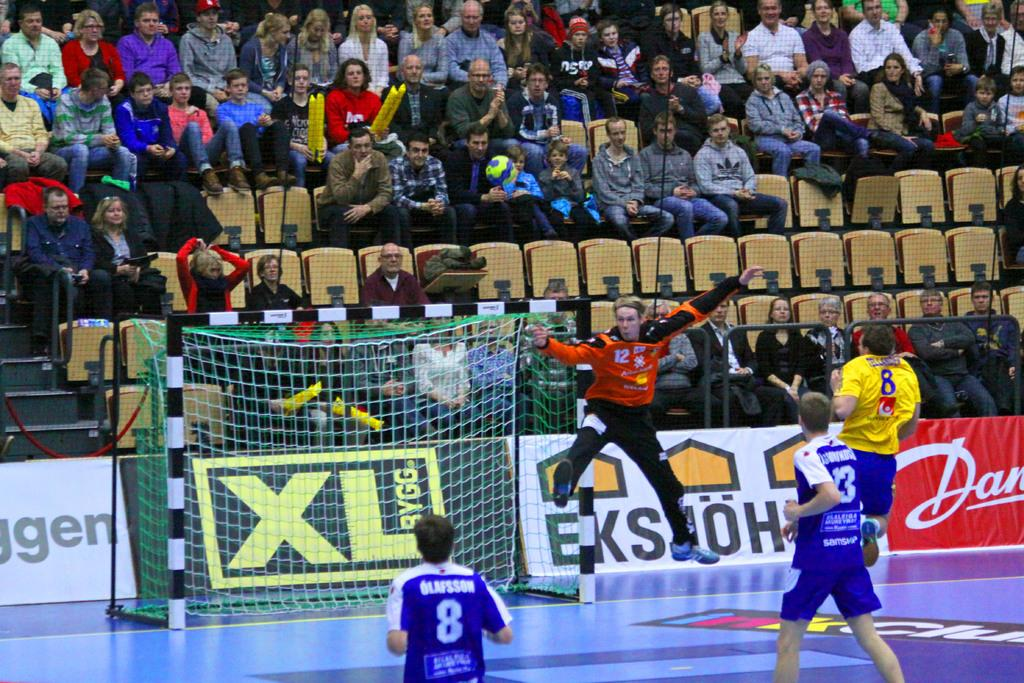What are the persons in the image doing? The persons in the image are playing on the ground. What can be seen in the background of the image? There is a net, chairs, and stairs in the background of the image. Are there any other people visible in the image? Yes, there are additional persons in the background of the image. What type of drink is being served at the protest in the image? There is no protest or drink present in the image; it features persons playing on the ground with a background containing a net, chairs, and stairs. 